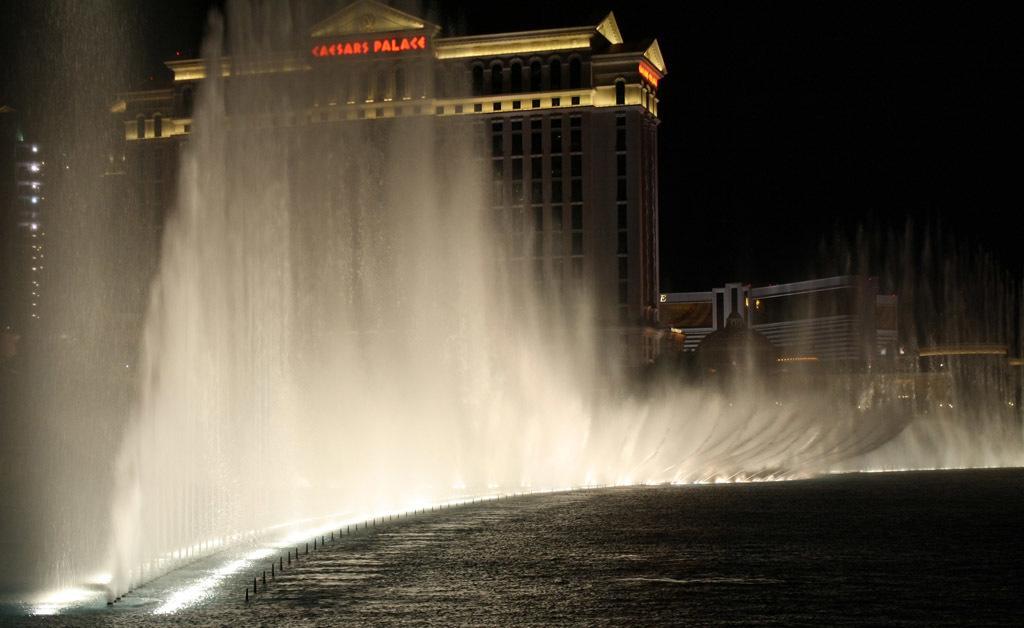Can you describe this image briefly? In this picture I can observe water fountains in the river. In the background there are buildings and I can observe sky which is completely dark. 